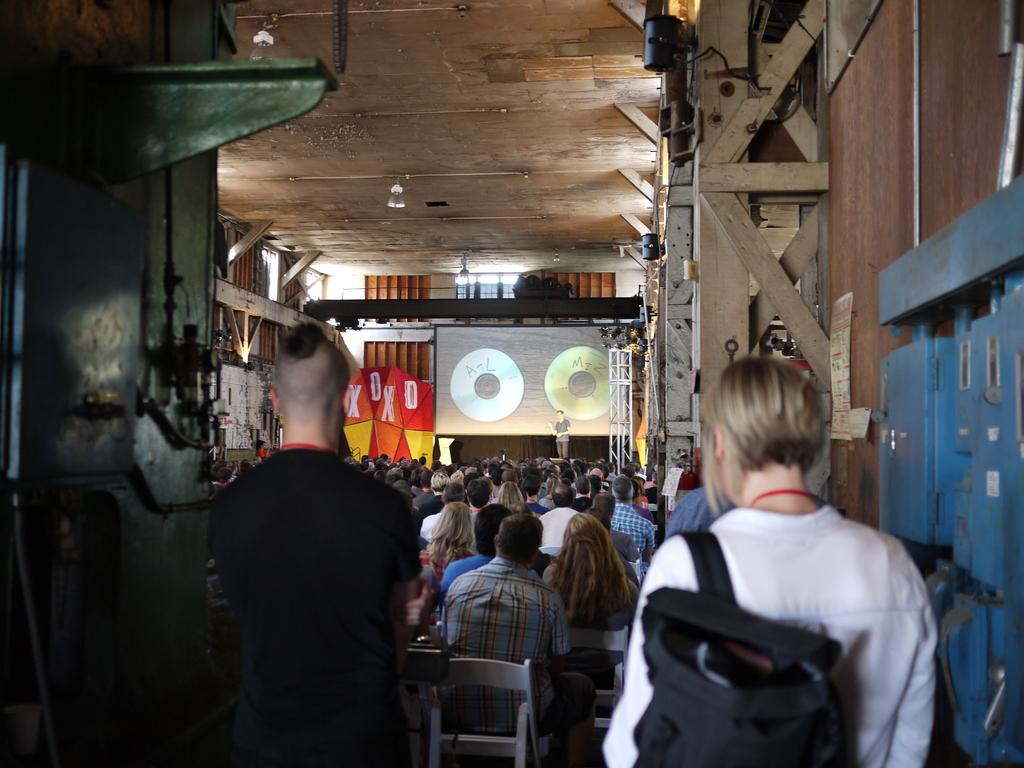What are the people in the image doing? There are persons sitting on chairs in the image. What is the man in the image doing? There is a man standing on a stage in the image. What is present in the image that might display information or visuals? There is a screen in the image. What can be seen in the image that might provide illumination? There are lights in the image. What type of loaf is being served to the audience in the image? There is no loaf present in the image; the focus is on the people sitting on chairs, the man standing on the stage, the screen, and the lights. How many dolls are visible on the stage in the image? There are no dolls present in the image; the focus is on the man standing on the stage. 